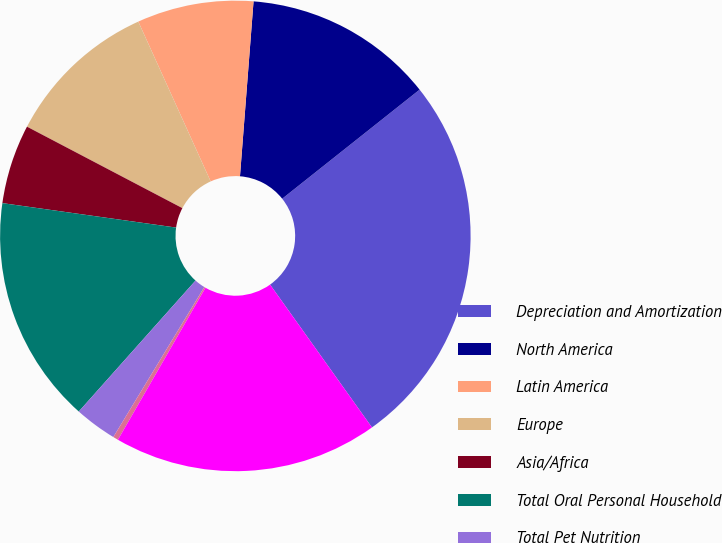Convert chart to OTSL. <chart><loc_0><loc_0><loc_500><loc_500><pie_chart><fcel>Depreciation and Amortization<fcel>North America<fcel>Latin America<fcel>Europe<fcel>Asia/Africa<fcel>Total Oral Personal Household<fcel>Total Pet Nutrition<fcel>Total Corporate<fcel>Total Depreciation and<nl><fcel>25.82%<fcel>13.09%<fcel>8.0%<fcel>10.55%<fcel>5.46%<fcel>15.64%<fcel>2.91%<fcel>0.36%<fcel>18.18%<nl></chart> 